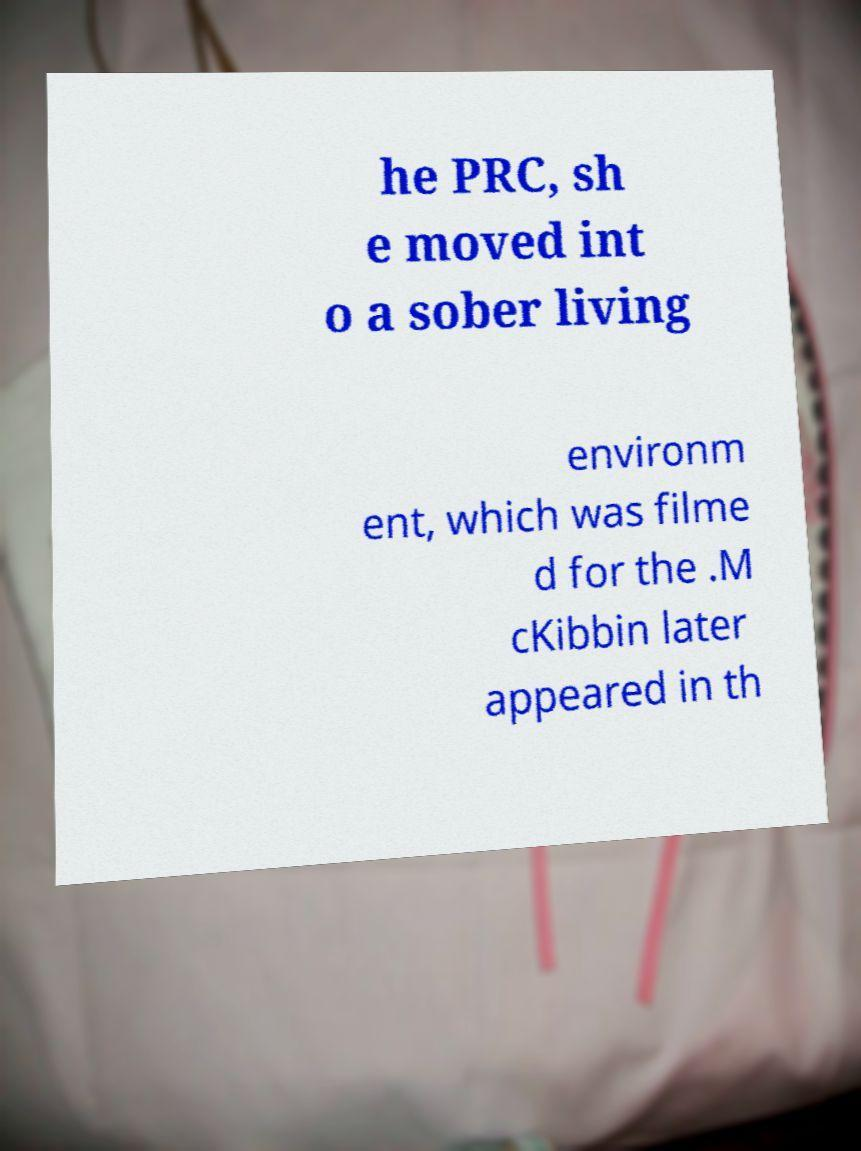Please identify and transcribe the text found in this image. he PRC, sh e moved int o a sober living environm ent, which was filme d for the .M cKibbin later appeared in th 